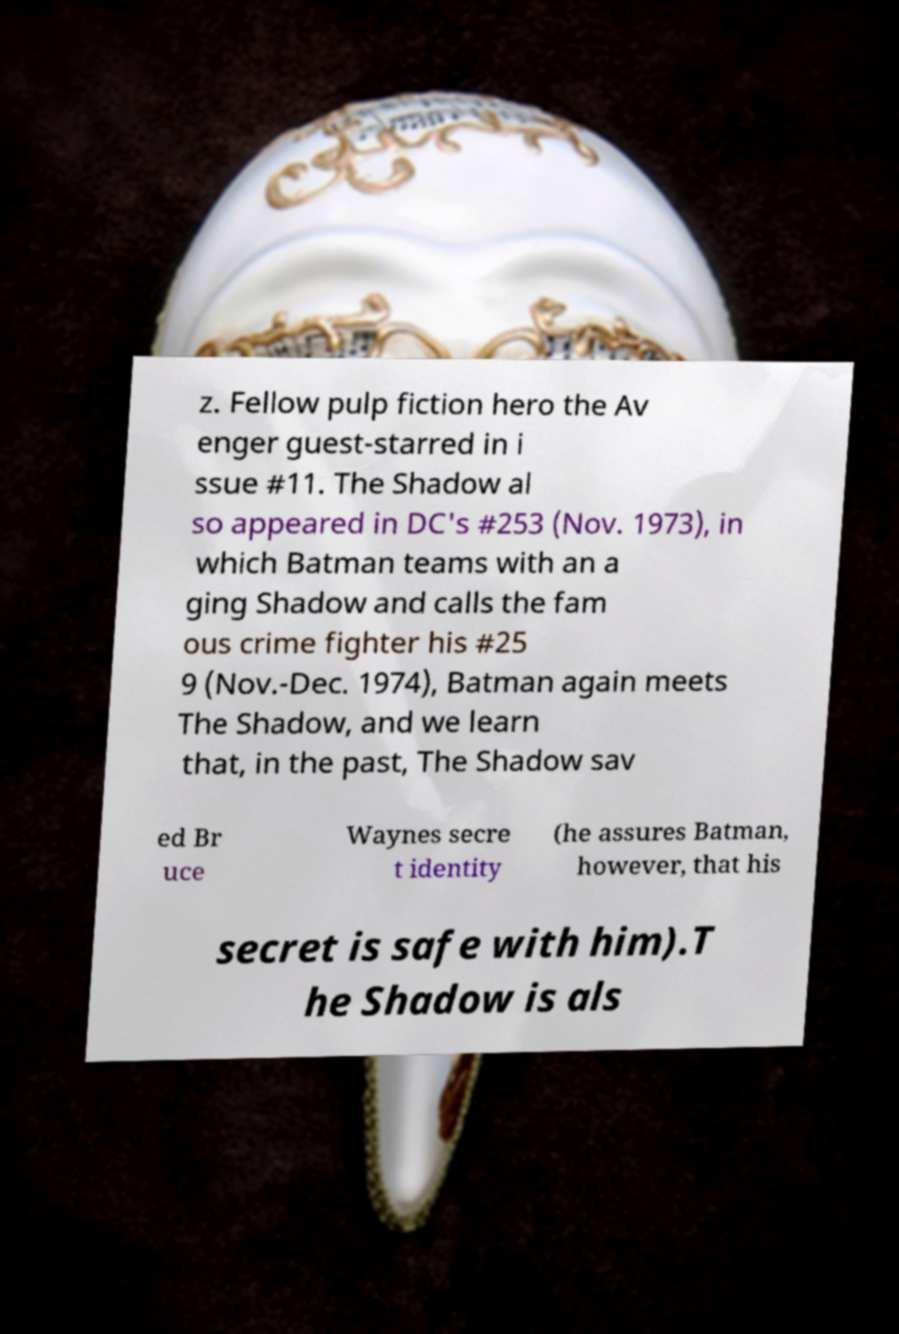I need the written content from this picture converted into text. Can you do that? z. Fellow pulp fiction hero the Av enger guest-starred in i ssue #11. The Shadow al so appeared in DC's #253 (Nov. 1973), in which Batman teams with an a ging Shadow and calls the fam ous crime fighter his #25 9 (Nov.-Dec. 1974), Batman again meets The Shadow, and we learn that, in the past, The Shadow sav ed Br uce Waynes secre t identity (he assures Batman, however, that his secret is safe with him).T he Shadow is als 